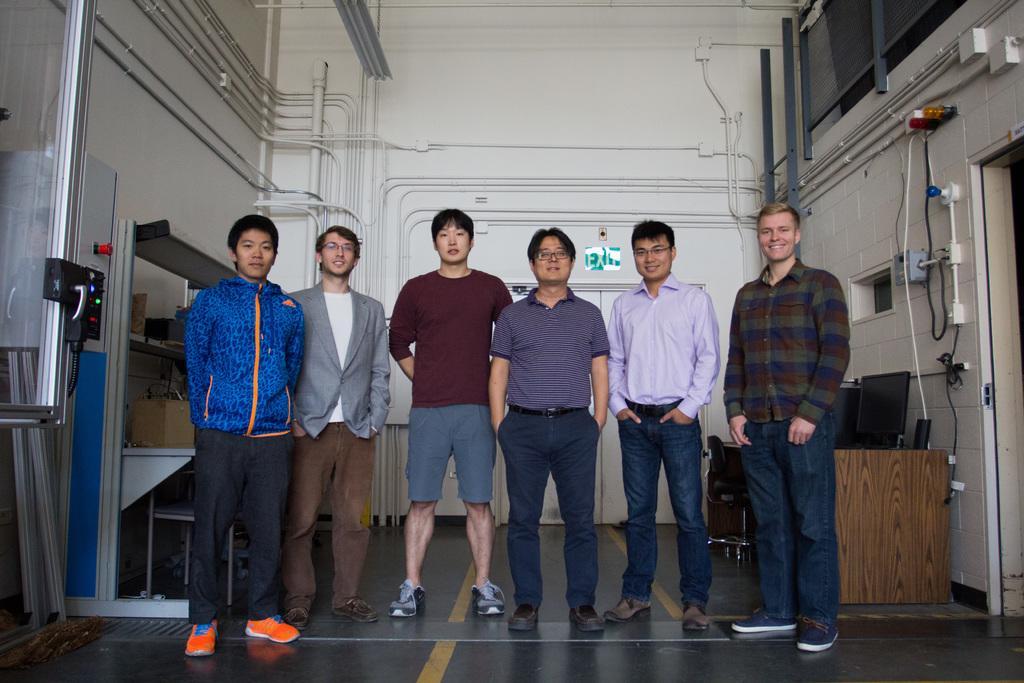Describe this image in one or two sentences. In this image we can see few people standing on the floor, there is a system on the table, two chairs, few pipes, lights, boxes, a board and few objects attached to the wall and there is a rack with few objects and there are few metal objects beside the rack on the left side and a door in the background. 